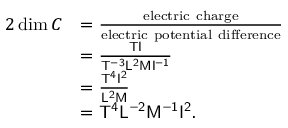Convert formula to latex. <formula><loc_0><loc_0><loc_500><loc_500>{ \begin{array} { r l } { { 2 } \dim C } & { = { \frac { e l e c t r i c c h \arg e } { e l e c t r i c p o t e n t i a l d i f f e r e n c e } } } \\ & { = { \frac { { T } { I } } { { T ^ { - 3 } } { L ^ { 2 } } { M } { I ^ { - 1 } } } } } \\ & { = { \frac { { T ^ { 4 } } { I ^ { 2 } } } { { L ^ { 2 } } { M } } } } \\ & { = { T ^ { 4 } } { L ^ { - 2 } } { M ^ { - 1 } } { I ^ { 2 } } . } \end{array} }</formula> 